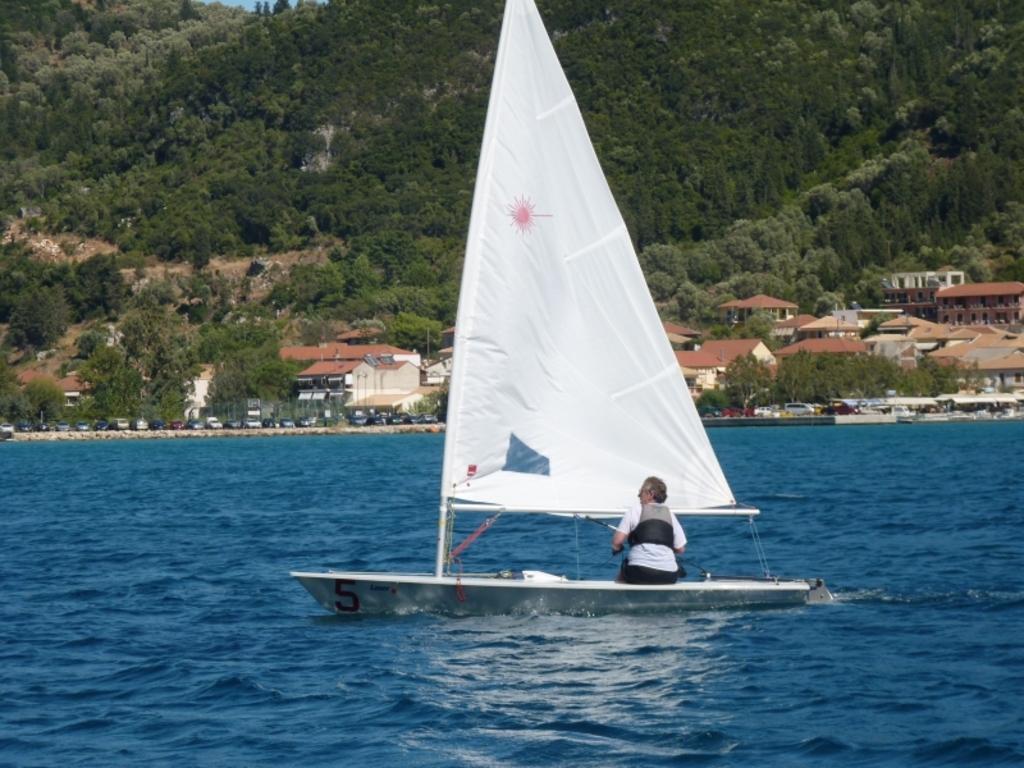Can you describe this image briefly? In the foreground of this image, there is a boat on which a person is sitting on it. The boat is moving on the water. In the background, there are trees, few buildings, vehicles and the sheds. 